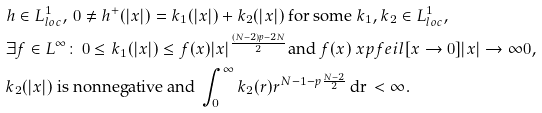Convert formula to latex. <formula><loc_0><loc_0><loc_500><loc_500>& h \in L ^ { 1 } _ { l o c } , \, 0 \neq h ^ { + } ( | x | ) = k _ { 1 } ( | x | ) + k _ { 2 } ( | x | ) \text { for some } k _ { 1 } , k _ { 2 } \in L ^ { 1 } _ { l o c } , \\ & \exists f \in L ^ { \infty } \colon \, 0 \leq k _ { 1 } ( | x | ) \leq f ( x ) | x | ^ { \frac { ( N - 2 ) p - 2 N } { 2 } } \text {and } f ( x ) \ x p f e i l [ x \to 0 ] { | x | \to \infty } 0 , \\ & k _ { 2 } ( | x | ) \text { is nonnegative and } \int _ { 0 } ^ { \infty } k _ { 2 } ( r ) r ^ { N - 1 - p \frac { N - 2 } { 2 } } \, \text {dr} \, < \infty .</formula> 